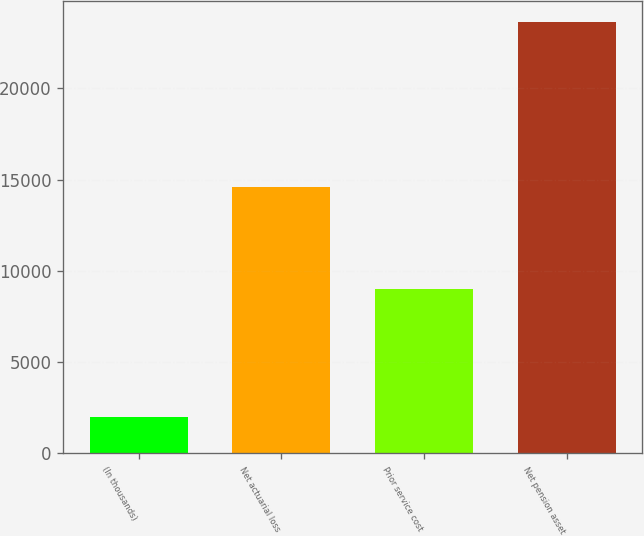Convert chart. <chart><loc_0><loc_0><loc_500><loc_500><bar_chart><fcel>(In thousands)<fcel>Net actuarial loss<fcel>Prior service cost<fcel>Net pension asset<nl><fcel>2012<fcel>14605<fcel>9012<fcel>23617<nl></chart> 